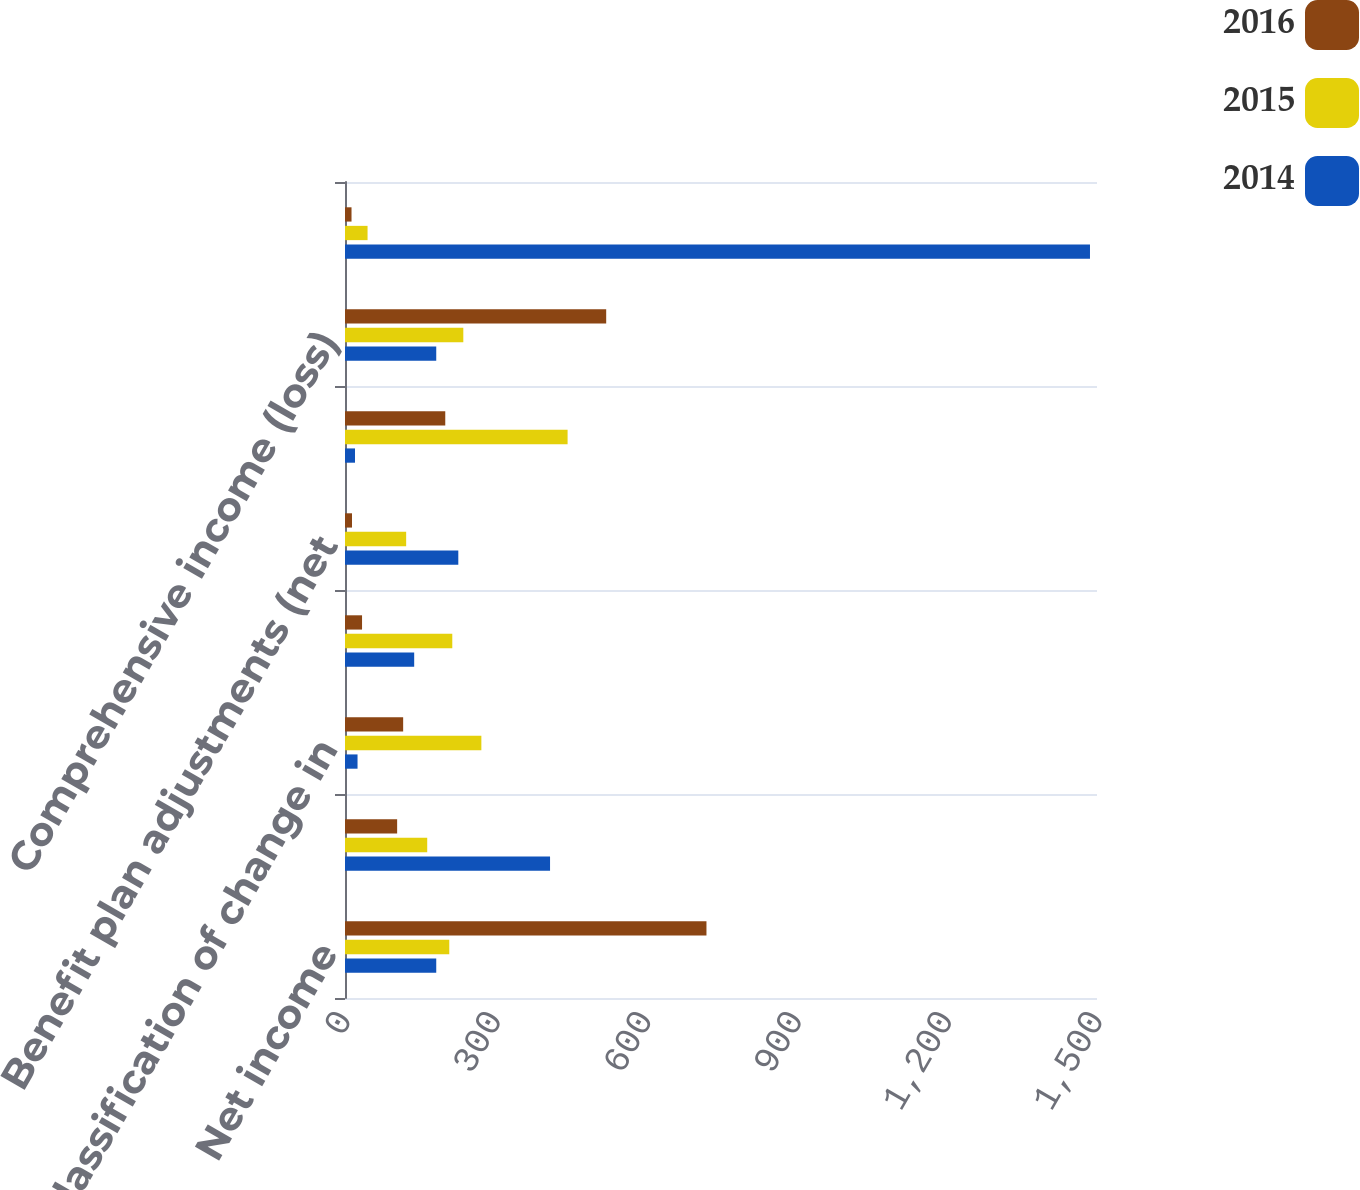Convert chart. <chart><loc_0><loc_0><loc_500><loc_500><stacked_bar_chart><ecel><fcel>Net income<fcel>Change in fair value of hedge<fcel>Reclassification of change in<fcel>Foreign currency translation<fcel>Benefit plan adjustments (net<fcel>Total other comprehensive<fcel>Comprehensive income (loss)<fcel>Comprehensive (income) loss<nl><fcel>2016<fcel>721<fcel>104<fcel>116<fcel>34<fcel>14<fcel>200<fcel>521<fcel>13<nl><fcel>2015<fcel>208<fcel>164<fcel>272<fcel>214<fcel>122<fcel>444<fcel>236<fcel>45<nl><fcel>2014<fcel>182<fcel>409<fcel>25<fcel>138<fcel>226<fcel>20<fcel>182<fcel>1486<nl></chart> 